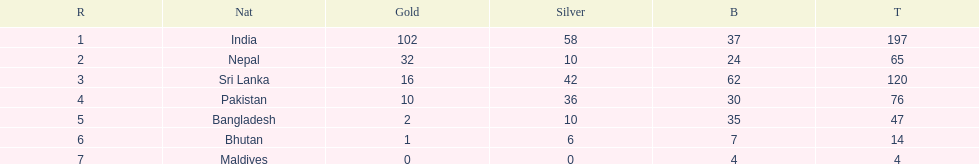Name the first country on the table? India. 